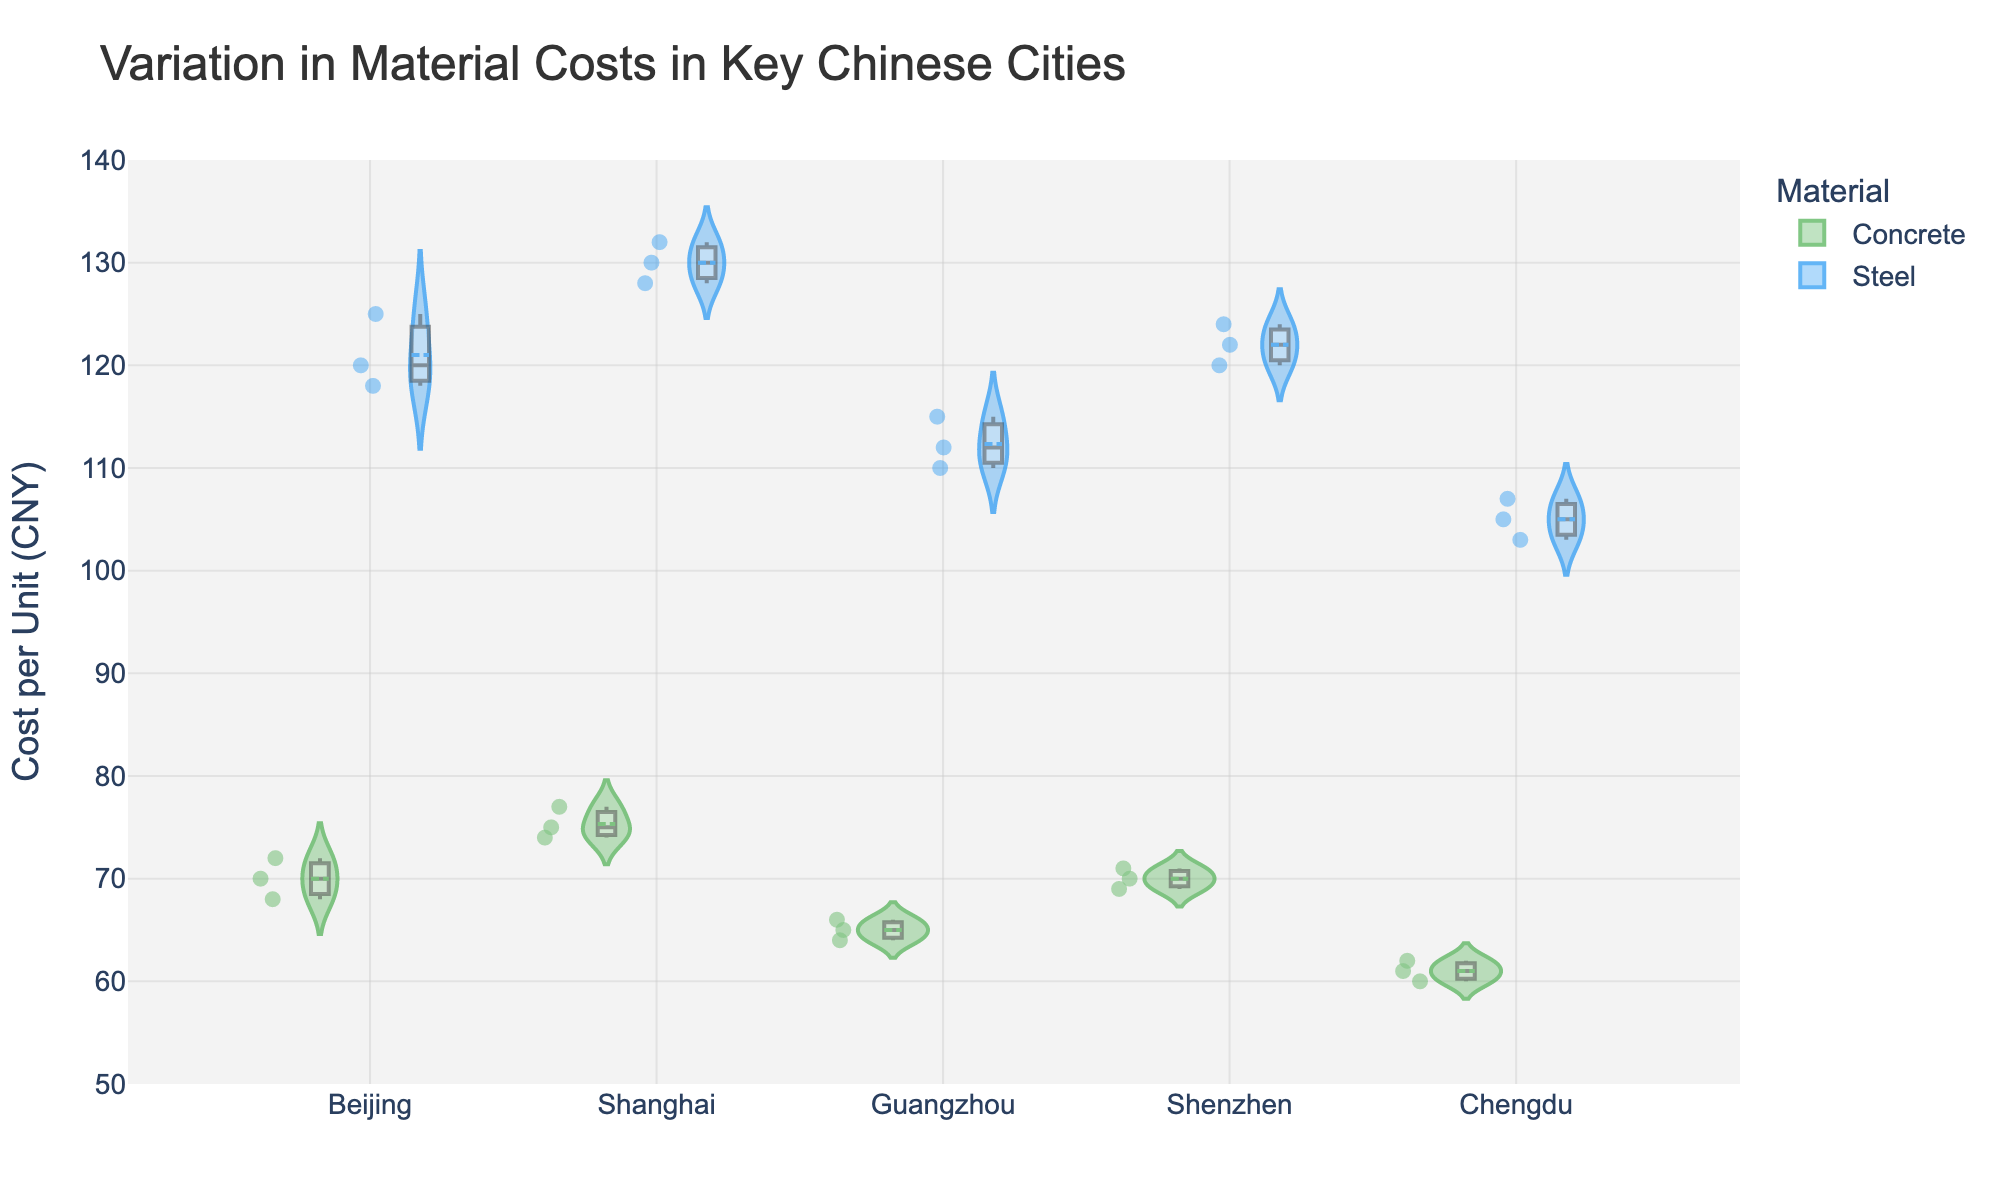What is the title of the figure? The title is placed at the top of the figure and describes what is being visualized.
Answer: Variation in Material Costs in Key Chinese Cities How is the data segmented in the figure? The data is segmented by city on the x-axis and by material (Concrete and Steel) through color differentiation. Concrete is represented in green, and Steel is in blue.
Answer: By city and material Which city has the highest median cost for Concrete? The median value is indicated by the line inside the box within each violin plot. Identify the highest median value for Concrete across the cities.
Answer: Shanghai Which material has the highest variation in cost in Guangzhou? The spread of the violin plot indicates the variation in cost. For Guangzhou, observe the width of the violin plots for Concrete and Steel to determine which one shows greater distribution.
Answer: Steel What is the range of Steel costs in Shanghai? The range can be determined by the minimum and maximum points (the ends of the distribution) of the Steel violin plot for Shanghai.
Answer: 128 to 132 CNY Is the median cost of Concrete higher in Beijing or Chengdu? Compare the median lines inside the boxes for Concrete in both Beijing and Chengdu.
Answer: Beijing Which city has the lowest median cost for Steel? The median line within the violin plot for Steel should be examined across all cities to identify the lowest.
Answer: Chengdu What is the price difference between the highest median cost of Concrete and Steel in Shenzhen? Find the median lines for both Concrete and Steel in Shenzhen and calculate the difference between them.
Answer: 52 CNY In which city does Steel exhibit the least variation? Look at the width of the Steel violin plots across all cities. The city with the narrowest plot will have the least variation.
Answer: Chengdu Between Beijing and Shanghai, which city shows a higher average Steel cost? For each city, sum all Steel cost data points and divide by the number of data points to get the average, then compare the two.
Answer: Shanghai 